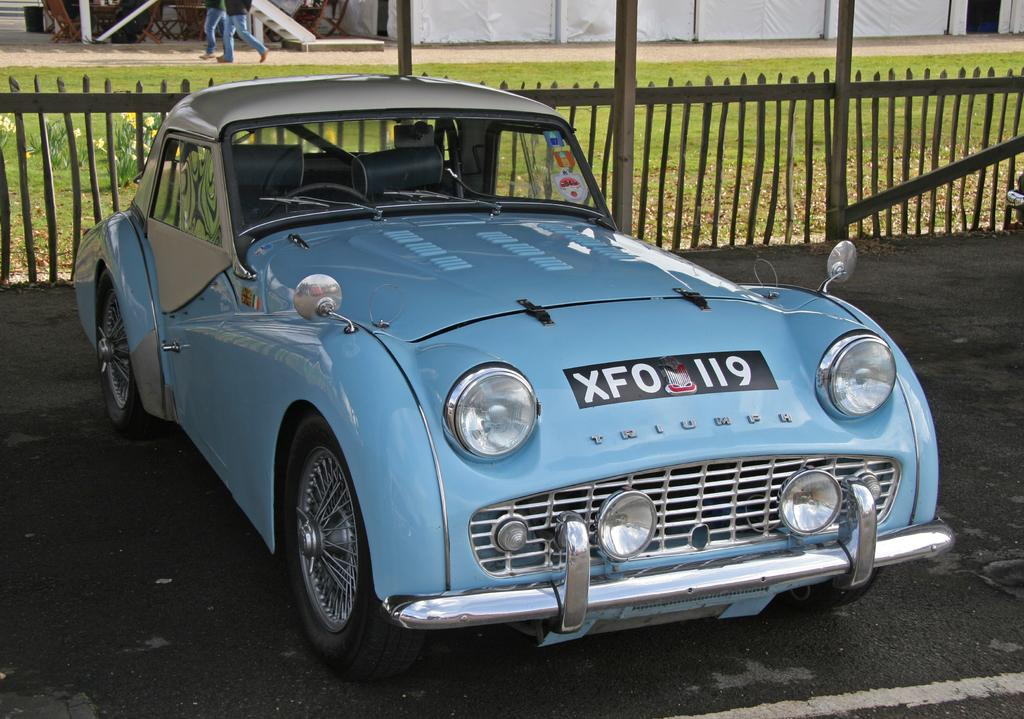What color is the car in the image? The car in the image is light blue. What is the car doing in the image? The car is parked. Are there any people visible in the image? Yes, there are people walking in the top left corner of the image. What is the governor's opinion on the car's parking location in the image? There is no information about the governor's opinion in the image, as the focus is on the car and people walking. 